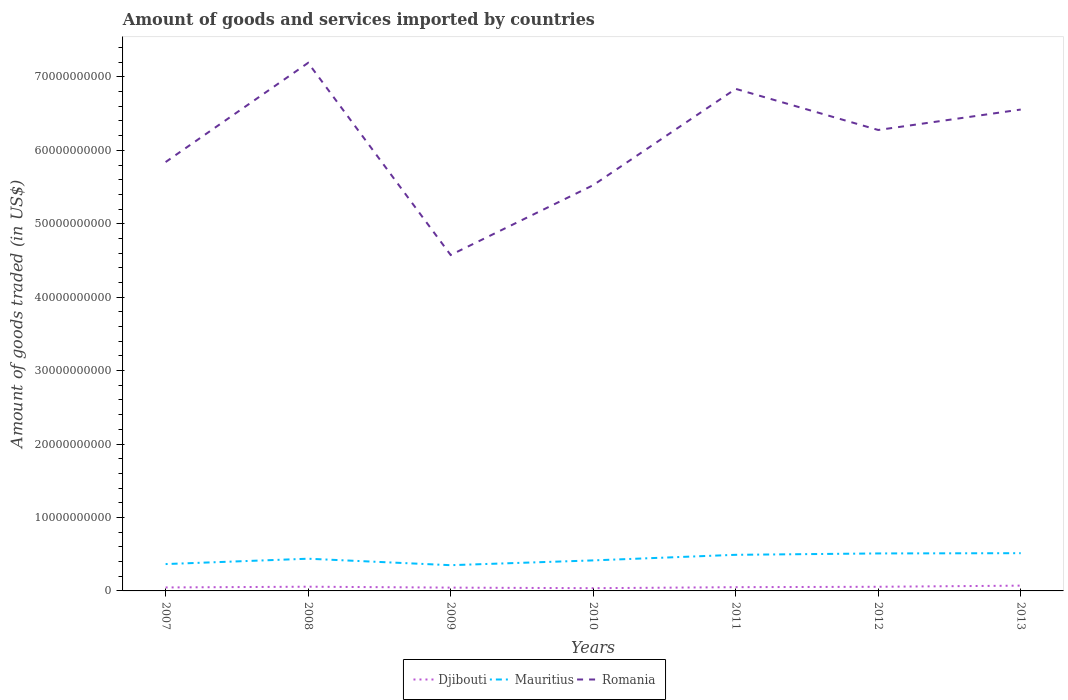Does the line corresponding to Djibouti intersect with the line corresponding to Romania?
Offer a terse response. No. Is the number of lines equal to the number of legend labels?
Offer a terse response. Yes. Across all years, what is the maximum total amount of goods and services imported in Mauritius?
Give a very brief answer. 3.50e+09. In which year was the total amount of goods and services imported in Romania maximum?
Give a very brief answer. 2009. What is the total total amount of goods and services imported in Romania in the graph?
Offer a very short reply. 5.60e+09. What is the difference between the highest and the second highest total amount of goods and services imported in Djibouti?
Offer a very short reply. 3.46e+08. Is the total amount of goods and services imported in Mauritius strictly greater than the total amount of goods and services imported in Djibouti over the years?
Your answer should be compact. No. What is the difference between two consecutive major ticks on the Y-axis?
Provide a succinct answer. 1.00e+1. Does the graph contain any zero values?
Your answer should be compact. No. Does the graph contain grids?
Provide a succinct answer. No. Where does the legend appear in the graph?
Provide a succinct answer. Bottom center. What is the title of the graph?
Your answer should be very brief. Amount of goods and services imported by countries. Does "Bahrain" appear as one of the legend labels in the graph?
Keep it short and to the point. No. What is the label or title of the Y-axis?
Your answer should be compact. Amount of goods traded (in US$). What is the Amount of goods traded (in US$) of Djibouti in 2007?
Provide a succinct answer. 4.73e+08. What is the Amount of goods traded (in US$) in Mauritius in 2007?
Offer a terse response. 3.66e+09. What is the Amount of goods traded (in US$) of Romania in 2007?
Offer a terse response. 5.84e+1. What is the Amount of goods traded (in US$) of Djibouti in 2008?
Your response must be concise. 5.74e+08. What is the Amount of goods traded (in US$) in Mauritius in 2008?
Provide a succinct answer. 4.39e+09. What is the Amount of goods traded (in US$) in Romania in 2008?
Your answer should be very brief. 7.19e+1. What is the Amount of goods traded (in US$) in Djibouti in 2009?
Give a very brief answer. 4.51e+08. What is the Amount of goods traded (in US$) of Mauritius in 2009?
Your response must be concise. 3.50e+09. What is the Amount of goods traded (in US$) of Romania in 2009?
Provide a succinct answer. 4.57e+1. What is the Amount of goods traded (in US$) of Djibouti in 2010?
Offer a very short reply. 3.74e+08. What is the Amount of goods traded (in US$) in Mauritius in 2010?
Your answer should be very brief. 4.16e+09. What is the Amount of goods traded (in US$) in Romania in 2010?
Provide a short and direct response. 5.53e+1. What is the Amount of goods traded (in US$) of Djibouti in 2011?
Make the answer very short. 5.11e+08. What is the Amount of goods traded (in US$) in Mauritius in 2011?
Your answer should be compact. 4.92e+09. What is the Amount of goods traded (in US$) in Romania in 2011?
Make the answer very short. 6.84e+1. What is the Amount of goods traded (in US$) in Djibouti in 2012?
Your response must be concise. 5.64e+08. What is the Amount of goods traded (in US$) of Mauritius in 2012?
Give a very brief answer. 5.10e+09. What is the Amount of goods traded (in US$) in Romania in 2012?
Your answer should be compact. 6.28e+1. What is the Amount of goods traded (in US$) of Djibouti in 2013?
Give a very brief answer. 7.19e+08. What is the Amount of goods traded (in US$) in Mauritius in 2013?
Ensure brevity in your answer.  5.14e+09. What is the Amount of goods traded (in US$) in Romania in 2013?
Your answer should be very brief. 6.56e+1. Across all years, what is the maximum Amount of goods traded (in US$) of Djibouti?
Your answer should be very brief. 7.19e+08. Across all years, what is the maximum Amount of goods traded (in US$) in Mauritius?
Provide a short and direct response. 5.14e+09. Across all years, what is the maximum Amount of goods traded (in US$) in Romania?
Your answer should be compact. 7.19e+1. Across all years, what is the minimum Amount of goods traded (in US$) in Djibouti?
Your answer should be compact. 3.74e+08. Across all years, what is the minimum Amount of goods traded (in US$) in Mauritius?
Make the answer very short. 3.50e+09. Across all years, what is the minimum Amount of goods traded (in US$) of Romania?
Make the answer very short. 4.57e+1. What is the total Amount of goods traded (in US$) in Djibouti in the graph?
Make the answer very short. 3.67e+09. What is the total Amount of goods traded (in US$) in Mauritius in the graph?
Keep it short and to the point. 3.09e+1. What is the total Amount of goods traded (in US$) in Romania in the graph?
Your answer should be very brief. 4.28e+11. What is the difference between the Amount of goods traded (in US$) in Djibouti in 2007 and that in 2008?
Give a very brief answer. -1.01e+08. What is the difference between the Amount of goods traded (in US$) in Mauritius in 2007 and that in 2008?
Make the answer very short. -7.30e+08. What is the difference between the Amount of goods traded (in US$) of Romania in 2007 and that in 2008?
Offer a terse response. -1.35e+1. What is the difference between the Amount of goods traded (in US$) of Djibouti in 2007 and that in 2009?
Your answer should be compact. 2.25e+07. What is the difference between the Amount of goods traded (in US$) in Mauritius in 2007 and that in 2009?
Your answer should be very brief. 1.52e+08. What is the difference between the Amount of goods traded (in US$) of Romania in 2007 and that in 2009?
Keep it short and to the point. 1.27e+1. What is the difference between the Amount of goods traded (in US$) of Djibouti in 2007 and that in 2010?
Make the answer very short. 9.93e+07. What is the difference between the Amount of goods traded (in US$) in Mauritius in 2007 and that in 2010?
Provide a short and direct response. -5.01e+08. What is the difference between the Amount of goods traded (in US$) of Romania in 2007 and that in 2010?
Provide a succinct answer. 3.15e+09. What is the difference between the Amount of goods traded (in US$) of Djibouti in 2007 and that in 2011?
Make the answer very short. -3.74e+07. What is the difference between the Amount of goods traded (in US$) of Mauritius in 2007 and that in 2011?
Offer a terse response. -1.26e+09. What is the difference between the Amount of goods traded (in US$) of Romania in 2007 and that in 2011?
Provide a short and direct response. -9.97e+09. What is the difference between the Amount of goods traded (in US$) in Djibouti in 2007 and that in 2012?
Give a very brief answer. -9.12e+07. What is the difference between the Amount of goods traded (in US$) in Mauritius in 2007 and that in 2012?
Your answer should be very brief. -1.45e+09. What is the difference between the Amount of goods traded (in US$) in Romania in 2007 and that in 2012?
Provide a succinct answer. -4.37e+09. What is the difference between the Amount of goods traded (in US$) of Djibouti in 2007 and that in 2013?
Your answer should be very brief. -2.46e+08. What is the difference between the Amount of goods traded (in US$) in Mauritius in 2007 and that in 2013?
Your answer should be very brief. -1.48e+09. What is the difference between the Amount of goods traded (in US$) of Romania in 2007 and that in 2013?
Provide a short and direct response. -7.15e+09. What is the difference between the Amount of goods traded (in US$) of Djibouti in 2008 and that in 2009?
Your answer should be compact. 1.23e+08. What is the difference between the Amount of goods traded (in US$) in Mauritius in 2008 and that in 2009?
Provide a succinct answer. 8.82e+08. What is the difference between the Amount of goods traded (in US$) of Romania in 2008 and that in 2009?
Provide a short and direct response. 2.62e+1. What is the difference between the Amount of goods traded (in US$) in Djibouti in 2008 and that in 2010?
Your answer should be compact. 2.00e+08. What is the difference between the Amount of goods traded (in US$) of Mauritius in 2008 and that in 2010?
Your response must be concise. 2.29e+08. What is the difference between the Amount of goods traded (in US$) of Romania in 2008 and that in 2010?
Provide a short and direct response. 1.67e+1. What is the difference between the Amount of goods traded (in US$) of Djibouti in 2008 and that in 2011?
Offer a terse response. 6.36e+07. What is the difference between the Amount of goods traded (in US$) in Mauritius in 2008 and that in 2011?
Provide a succinct answer. -5.31e+08. What is the difference between the Amount of goods traded (in US$) in Romania in 2008 and that in 2011?
Your answer should be very brief. 3.54e+09. What is the difference between the Amount of goods traded (in US$) of Djibouti in 2008 and that in 2012?
Offer a very short reply. 9.70e+06. What is the difference between the Amount of goods traded (in US$) in Mauritius in 2008 and that in 2012?
Offer a very short reply. -7.19e+08. What is the difference between the Amount of goods traded (in US$) of Romania in 2008 and that in 2012?
Provide a succinct answer. 9.14e+09. What is the difference between the Amount of goods traded (in US$) of Djibouti in 2008 and that in 2013?
Your answer should be very brief. -1.45e+08. What is the difference between the Amount of goods traded (in US$) in Mauritius in 2008 and that in 2013?
Offer a terse response. -7.53e+08. What is the difference between the Amount of goods traded (in US$) of Romania in 2008 and that in 2013?
Provide a short and direct response. 6.36e+09. What is the difference between the Amount of goods traded (in US$) in Djibouti in 2009 and that in 2010?
Offer a terse response. 7.68e+07. What is the difference between the Amount of goods traded (in US$) in Mauritius in 2009 and that in 2010?
Make the answer very short. -6.53e+08. What is the difference between the Amount of goods traded (in US$) of Romania in 2009 and that in 2010?
Offer a terse response. -9.51e+09. What is the difference between the Amount of goods traded (in US$) in Djibouti in 2009 and that in 2011?
Make the answer very short. -5.99e+07. What is the difference between the Amount of goods traded (in US$) of Mauritius in 2009 and that in 2011?
Give a very brief answer. -1.41e+09. What is the difference between the Amount of goods traded (in US$) in Romania in 2009 and that in 2011?
Offer a very short reply. -2.26e+1. What is the difference between the Amount of goods traded (in US$) in Djibouti in 2009 and that in 2012?
Your answer should be compact. -1.14e+08. What is the difference between the Amount of goods traded (in US$) of Mauritius in 2009 and that in 2012?
Offer a very short reply. -1.60e+09. What is the difference between the Amount of goods traded (in US$) in Romania in 2009 and that in 2012?
Your answer should be very brief. -1.70e+1. What is the difference between the Amount of goods traded (in US$) in Djibouti in 2009 and that in 2013?
Your response must be concise. -2.69e+08. What is the difference between the Amount of goods traded (in US$) in Mauritius in 2009 and that in 2013?
Provide a short and direct response. -1.64e+09. What is the difference between the Amount of goods traded (in US$) in Romania in 2009 and that in 2013?
Your answer should be very brief. -1.98e+1. What is the difference between the Amount of goods traded (in US$) in Djibouti in 2010 and that in 2011?
Keep it short and to the point. -1.37e+08. What is the difference between the Amount of goods traded (in US$) of Mauritius in 2010 and that in 2011?
Provide a succinct answer. -7.61e+08. What is the difference between the Amount of goods traded (in US$) in Romania in 2010 and that in 2011?
Make the answer very short. -1.31e+1. What is the difference between the Amount of goods traded (in US$) of Djibouti in 2010 and that in 2012?
Your answer should be compact. -1.91e+08. What is the difference between the Amount of goods traded (in US$) of Mauritius in 2010 and that in 2012?
Give a very brief answer. -9.48e+08. What is the difference between the Amount of goods traded (in US$) in Romania in 2010 and that in 2012?
Your answer should be compact. -7.52e+09. What is the difference between the Amount of goods traded (in US$) in Djibouti in 2010 and that in 2013?
Give a very brief answer. -3.46e+08. What is the difference between the Amount of goods traded (in US$) in Mauritius in 2010 and that in 2013?
Make the answer very short. -9.82e+08. What is the difference between the Amount of goods traded (in US$) of Romania in 2010 and that in 2013?
Make the answer very short. -1.03e+1. What is the difference between the Amount of goods traded (in US$) in Djibouti in 2011 and that in 2012?
Ensure brevity in your answer.  -5.39e+07. What is the difference between the Amount of goods traded (in US$) of Mauritius in 2011 and that in 2012?
Give a very brief answer. -1.87e+08. What is the difference between the Amount of goods traded (in US$) in Romania in 2011 and that in 2012?
Provide a short and direct response. 5.60e+09. What is the difference between the Amount of goods traded (in US$) in Djibouti in 2011 and that in 2013?
Offer a terse response. -2.09e+08. What is the difference between the Amount of goods traded (in US$) of Mauritius in 2011 and that in 2013?
Give a very brief answer. -2.22e+08. What is the difference between the Amount of goods traded (in US$) of Romania in 2011 and that in 2013?
Keep it short and to the point. 2.82e+09. What is the difference between the Amount of goods traded (in US$) of Djibouti in 2012 and that in 2013?
Your answer should be compact. -1.55e+08. What is the difference between the Amount of goods traded (in US$) of Mauritius in 2012 and that in 2013?
Provide a succinct answer. -3.42e+07. What is the difference between the Amount of goods traded (in US$) of Romania in 2012 and that in 2013?
Make the answer very short. -2.78e+09. What is the difference between the Amount of goods traded (in US$) of Djibouti in 2007 and the Amount of goods traded (in US$) of Mauritius in 2008?
Provide a short and direct response. -3.91e+09. What is the difference between the Amount of goods traded (in US$) in Djibouti in 2007 and the Amount of goods traded (in US$) in Romania in 2008?
Ensure brevity in your answer.  -7.14e+1. What is the difference between the Amount of goods traded (in US$) in Mauritius in 2007 and the Amount of goods traded (in US$) in Romania in 2008?
Give a very brief answer. -6.83e+1. What is the difference between the Amount of goods traded (in US$) in Djibouti in 2007 and the Amount of goods traded (in US$) in Mauritius in 2009?
Your answer should be very brief. -3.03e+09. What is the difference between the Amount of goods traded (in US$) of Djibouti in 2007 and the Amount of goods traded (in US$) of Romania in 2009?
Ensure brevity in your answer.  -4.53e+1. What is the difference between the Amount of goods traded (in US$) of Mauritius in 2007 and the Amount of goods traded (in US$) of Romania in 2009?
Keep it short and to the point. -4.21e+1. What is the difference between the Amount of goods traded (in US$) of Djibouti in 2007 and the Amount of goods traded (in US$) of Mauritius in 2010?
Make the answer very short. -3.68e+09. What is the difference between the Amount of goods traded (in US$) in Djibouti in 2007 and the Amount of goods traded (in US$) in Romania in 2010?
Your response must be concise. -5.48e+1. What is the difference between the Amount of goods traded (in US$) in Mauritius in 2007 and the Amount of goods traded (in US$) in Romania in 2010?
Your response must be concise. -5.16e+1. What is the difference between the Amount of goods traded (in US$) of Djibouti in 2007 and the Amount of goods traded (in US$) of Mauritius in 2011?
Provide a short and direct response. -4.44e+09. What is the difference between the Amount of goods traded (in US$) in Djibouti in 2007 and the Amount of goods traded (in US$) in Romania in 2011?
Provide a short and direct response. -6.79e+1. What is the difference between the Amount of goods traded (in US$) of Mauritius in 2007 and the Amount of goods traded (in US$) of Romania in 2011?
Your answer should be very brief. -6.47e+1. What is the difference between the Amount of goods traded (in US$) of Djibouti in 2007 and the Amount of goods traded (in US$) of Mauritius in 2012?
Make the answer very short. -4.63e+09. What is the difference between the Amount of goods traded (in US$) in Djibouti in 2007 and the Amount of goods traded (in US$) in Romania in 2012?
Offer a very short reply. -6.23e+1. What is the difference between the Amount of goods traded (in US$) in Mauritius in 2007 and the Amount of goods traded (in US$) in Romania in 2012?
Your answer should be very brief. -5.91e+1. What is the difference between the Amount of goods traded (in US$) of Djibouti in 2007 and the Amount of goods traded (in US$) of Mauritius in 2013?
Provide a succinct answer. -4.67e+09. What is the difference between the Amount of goods traded (in US$) in Djibouti in 2007 and the Amount of goods traded (in US$) in Romania in 2013?
Ensure brevity in your answer.  -6.51e+1. What is the difference between the Amount of goods traded (in US$) in Mauritius in 2007 and the Amount of goods traded (in US$) in Romania in 2013?
Your answer should be very brief. -6.19e+1. What is the difference between the Amount of goods traded (in US$) in Djibouti in 2008 and the Amount of goods traded (in US$) in Mauritius in 2009?
Give a very brief answer. -2.93e+09. What is the difference between the Amount of goods traded (in US$) of Djibouti in 2008 and the Amount of goods traded (in US$) of Romania in 2009?
Your answer should be compact. -4.52e+1. What is the difference between the Amount of goods traded (in US$) of Mauritius in 2008 and the Amount of goods traded (in US$) of Romania in 2009?
Keep it short and to the point. -4.14e+1. What is the difference between the Amount of goods traded (in US$) of Djibouti in 2008 and the Amount of goods traded (in US$) of Mauritius in 2010?
Your answer should be compact. -3.58e+09. What is the difference between the Amount of goods traded (in US$) in Djibouti in 2008 and the Amount of goods traded (in US$) in Romania in 2010?
Ensure brevity in your answer.  -5.47e+1. What is the difference between the Amount of goods traded (in US$) in Mauritius in 2008 and the Amount of goods traded (in US$) in Romania in 2010?
Your answer should be very brief. -5.09e+1. What is the difference between the Amount of goods traded (in US$) in Djibouti in 2008 and the Amount of goods traded (in US$) in Mauritius in 2011?
Ensure brevity in your answer.  -4.34e+09. What is the difference between the Amount of goods traded (in US$) of Djibouti in 2008 and the Amount of goods traded (in US$) of Romania in 2011?
Keep it short and to the point. -6.78e+1. What is the difference between the Amount of goods traded (in US$) of Mauritius in 2008 and the Amount of goods traded (in US$) of Romania in 2011?
Your answer should be compact. -6.40e+1. What is the difference between the Amount of goods traded (in US$) in Djibouti in 2008 and the Amount of goods traded (in US$) in Mauritius in 2012?
Your answer should be compact. -4.53e+09. What is the difference between the Amount of goods traded (in US$) of Djibouti in 2008 and the Amount of goods traded (in US$) of Romania in 2012?
Your answer should be very brief. -6.22e+1. What is the difference between the Amount of goods traded (in US$) in Mauritius in 2008 and the Amount of goods traded (in US$) in Romania in 2012?
Provide a short and direct response. -5.84e+1. What is the difference between the Amount of goods traded (in US$) in Djibouti in 2008 and the Amount of goods traded (in US$) in Mauritius in 2013?
Offer a very short reply. -4.56e+09. What is the difference between the Amount of goods traded (in US$) in Djibouti in 2008 and the Amount of goods traded (in US$) in Romania in 2013?
Your answer should be compact. -6.50e+1. What is the difference between the Amount of goods traded (in US$) of Mauritius in 2008 and the Amount of goods traded (in US$) of Romania in 2013?
Ensure brevity in your answer.  -6.12e+1. What is the difference between the Amount of goods traded (in US$) in Djibouti in 2009 and the Amount of goods traded (in US$) in Mauritius in 2010?
Provide a succinct answer. -3.71e+09. What is the difference between the Amount of goods traded (in US$) of Djibouti in 2009 and the Amount of goods traded (in US$) of Romania in 2010?
Your answer should be very brief. -5.48e+1. What is the difference between the Amount of goods traded (in US$) of Mauritius in 2009 and the Amount of goods traded (in US$) of Romania in 2010?
Provide a succinct answer. -5.17e+1. What is the difference between the Amount of goods traded (in US$) of Djibouti in 2009 and the Amount of goods traded (in US$) of Mauritius in 2011?
Make the answer very short. -4.47e+09. What is the difference between the Amount of goods traded (in US$) in Djibouti in 2009 and the Amount of goods traded (in US$) in Romania in 2011?
Ensure brevity in your answer.  -6.79e+1. What is the difference between the Amount of goods traded (in US$) of Mauritius in 2009 and the Amount of goods traded (in US$) of Romania in 2011?
Ensure brevity in your answer.  -6.49e+1. What is the difference between the Amount of goods traded (in US$) in Djibouti in 2009 and the Amount of goods traded (in US$) in Mauritius in 2012?
Make the answer very short. -4.65e+09. What is the difference between the Amount of goods traded (in US$) in Djibouti in 2009 and the Amount of goods traded (in US$) in Romania in 2012?
Keep it short and to the point. -6.23e+1. What is the difference between the Amount of goods traded (in US$) in Mauritius in 2009 and the Amount of goods traded (in US$) in Romania in 2012?
Keep it short and to the point. -5.93e+1. What is the difference between the Amount of goods traded (in US$) of Djibouti in 2009 and the Amount of goods traded (in US$) of Mauritius in 2013?
Provide a short and direct response. -4.69e+09. What is the difference between the Amount of goods traded (in US$) of Djibouti in 2009 and the Amount of goods traded (in US$) of Romania in 2013?
Offer a terse response. -6.51e+1. What is the difference between the Amount of goods traded (in US$) of Mauritius in 2009 and the Amount of goods traded (in US$) of Romania in 2013?
Offer a terse response. -6.20e+1. What is the difference between the Amount of goods traded (in US$) in Djibouti in 2010 and the Amount of goods traded (in US$) in Mauritius in 2011?
Keep it short and to the point. -4.54e+09. What is the difference between the Amount of goods traded (in US$) of Djibouti in 2010 and the Amount of goods traded (in US$) of Romania in 2011?
Offer a very short reply. -6.80e+1. What is the difference between the Amount of goods traded (in US$) of Mauritius in 2010 and the Amount of goods traded (in US$) of Romania in 2011?
Keep it short and to the point. -6.42e+1. What is the difference between the Amount of goods traded (in US$) in Djibouti in 2010 and the Amount of goods traded (in US$) in Mauritius in 2012?
Provide a short and direct response. -4.73e+09. What is the difference between the Amount of goods traded (in US$) in Djibouti in 2010 and the Amount of goods traded (in US$) in Romania in 2012?
Your answer should be compact. -6.24e+1. What is the difference between the Amount of goods traded (in US$) in Mauritius in 2010 and the Amount of goods traded (in US$) in Romania in 2012?
Ensure brevity in your answer.  -5.86e+1. What is the difference between the Amount of goods traded (in US$) of Djibouti in 2010 and the Amount of goods traded (in US$) of Mauritius in 2013?
Provide a succinct answer. -4.77e+09. What is the difference between the Amount of goods traded (in US$) in Djibouti in 2010 and the Amount of goods traded (in US$) in Romania in 2013?
Your answer should be compact. -6.52e+1. What is the difference between the Amount of goods traded (in US$) of Mauritius in 2010 and the Amount of goods traded (in US$) of Romania in 2013?
Offer a terse response. -6.14e+1. What is the difference between the Amount of goods traded (in US$) of Djibouti in 2011 and the Amount of goods traded (in US$) of Mauritius in 2012?
Offer a terse response. -4.59e+09. What is the difference between the Amount of goods traded (in US$) of Djibouti in 2011 and the Amount of goods traded (in US$) of Romania in 2012?
Keep it short and to the point. -6.23e+1. What is the difference between the Amount of goods traded (in US$) in Mauritius in 2011 and the Amount of goods traded (in US$) in Romania in 2012?
Offer a terse response. -5.79e+1. What is the difference between the Amount of goods traded (in US$) of Djibouti in 2011 and the Amount of goods traded (in US$) of Mauritius in 2013?
Give a very brief answer. -4.63e+09. What is the difference between the Amount of goods traded (in US$) in Djibouti in 2011 and the Amount of goods traded (in US$) in Romania in 2013?
Give a very brief answer. -6.50e+1. What is the difference between the Amount of goods traded (in US$) of Mauritius in 2011 and the Amount of goods traded (in US$) of Romania in 2013?
Your answer should be compact. -6.06e+1. What is the difference between the Amount of goods traded (in US$) in Djibouti in 2012 and the Amount of goods traded (in US$) in Mauritius in 2013?
Provide a succinct answer. -4.57e+09. What is the difference between the Amount of goods traded (in US$) in Djibouti in 2012 and the Amount of goods traded (in US$) in Romania in 2013?
Your response must be concise. -6.50e+1. What is the difference between the Amount of goods traded (in US$) in Mauritius in 2012 and the Amount of goods traded (in US$) in Romania in 2013?
Make the answer very short. -6.04e+1. What is the average Amount of goods traded (in US$) of Djibouti per year?
Ensure brevity in your answer.  5.24e+08. What is the average Amount of goods traded (in US$) in Mauritius per year?
Your answer should be compact. 4.41e+09. What is the average Amount of goods traded (in US$) of Romania per year?
Provide a succinct answer. 6.11e+1. In the year 2007, what is the difference between the Amount of goods traded (in US$) in Djibouti and Amount of goods traded (in US$) in Mauritius?
Make the answer very short. -3.18e+09. In the year 2007, what is the difference between the Amount of goods traded (in US$) in Djibouti and Amount of goods traded (in US$) in Romania?
Keep it short and to the point. -5.79e+1. In the year 2007, what is the difference between the Amount of goods traded (in US$) of Mauritius and Amount of goods traded (in US$) of Romania?
Ensure brevity in your answer.  -5.47e+1. In the year 2008, what is the difference between the Amount of goods traded (in US$) of Djibouti and Amount of goods traded (in US$) of Mauritius?
Ensure brevity in your answer.  -3.81e+09. In the year 2008, what is the difference between the Amount of goods traded (in US$) of Djibouti and Amount of goods traded (in US$) of Romania?
Your response must be concise. -7.13e+1. In the year 2008, what is the difference between the Amount of goods traded (in US$) in Mauritius and Amount of goods traded (in US$) in Romania?
Provide a short and direct response. -6.75e+1. In the year 2009, what is the difference between the Amount of goods traded (in US$) of Djibouti and Amount of goods traded (in US$) of Mauritius?
Your answer should be very brief. -3.05e+09. In the year 2009, what is the difference between the Amount of goods traded (in US$) in Djibouti and Amount of goods traded (in US$) in Romania?
Give a very brief answer. -4.53e+1. In the year 2009, what is the difference between the Amount of goods traded (in US$) of Mauritius and Amount of goods traded (in US$) of Romania?
Make the answer very short. -4.22e+1. In the year 2010, what is the difference between the Amount of goods traded (in US$) of Djibouti and Amount of goods traded (in US$) of Mauritius?
Provide a succinct answer. -3.78e+09. In the year 2010, what is the difference between the Amount of goods traded (in US$) of Djibouti and Amount of goods traded (in US$) of Romania?
Your answer should be compact. -5.49e+1. In the year 2010, what is the difference between the Amount of goods traded (in US$) of Mauritius and Amount of goods traded (in US$) of Romania?
Your answer should be compact. -5.11e+1. In the year 2011, what is the difference between the Amount of goods traded (in US$) in Djibouti and Amount of goods traded (in US$) in Mauritius?
Keep it short and to the point. -4.41e+09. In the year 2011, what is the difference between the Amount of goods traded (in US$) of Djibouti and Amount of goods traded (in US$) of Romania?
Your response must be concise. -6.79e+1. In the year 2011, what is the difference between the Amount of goods traded (in US$) of Mauritius and Amount of goods traded (in US$) of Romania?
Provide a short and direct response. -6.35e+1. In the year 2012, what is the difference between the Amount of goods traded (in US$) of Djibouti and Amount of goods traded (in US$) of Mauritius?
Provide a succinct answer. -4.54e+09. In the year 2012, what is the difference between the Amount of goods traded (in US$) in Djibouti and Amount of goods traded (in US$) in Romania?
Make the answer very short. -6.22e+1. In the year 2012, what is the difference between the Amount of goods traded (in US$) in Mauritius and Amount of goods traded (in US$) in Romania?
Offer a terse response. -5.77e+1. In the year 2013, what is the difference between the Amount of goods traded (in US$) in Djibouti and Amount of goods traded (in US$) in Mauritius?
Your response must be concise. -4.42e+09. In the year 2013, what is the difference between the Amount of goods traded (in US$) in Djibouti and Amount of goods traded (in US$) in Romania?
Make the answer very short. -6.48e+1. In the year 2013, what is the difference between the Amount of goods traded (in US$) in Mauritius and Amount of goods traded (in US$) in Romania?
Make the answer very short. -6.04e+1. What is the ratio of the Amount of goods traded (in US$) of Djibouti in 2007 to that in 2008?
Provide a short and direct response. 0.82. What is the ratio of the Amount of goods traded (in US$) of Mauritius in 2007 to that in 2008?
Make the answer very short. 0.83. What is the ratio of the Amount of goods traded (in US$) of Romania in 2007 to that in 2008?
Make the answer very short. 0.81. What is the ratio of the Amount of goods traded (in US$) in Mauritius in 2007 to that in 2009?
Offer a very short reply. 1.04. What is the ratio of the Amount of goods traded (in US$) in Romania in 2007 to that in 2009?
Make the answer very short. 1.28. What is the ratio of the Amount of goods traded (in US$) of Djibouti in 2007 to that in 2010?
Provide a succinct answer. 1.27. What is the ratio of the Amount of goods traded (in US$) of Mauritius in 2007 to that in 2010?
Ensure brevity in your answer.  0.88. What is the ratio of the Amount of goods traded (in US$) in Romania in 2007 to that in 2010?
Keep it short and to the point. 1.06. What is the ratio of the Amount of goods traded (in US$) in Djibouti in 2007 to that in 2011?
Offer a terse response. 0.93. What is the ratio of the Amount of goods traded (in US$) in Mauritius in 2007 to that in 2011?
Make the answer very short. 0.74. What is the ratio of the Amount of goods traded (in US$) of Romania in 2007 to that in 2011?
Offer a terse response. 0.85. What is the ratio of the Amount of goods traded (in US$) in Djibouti in 2007 to that in 2012?
Your answer should be very brief. 0.84. What is the ratio of the Amount of goods traded (in US$) in Mauritius in 2007 to that in 2012?
Keep it short and to the point. 0.72. What is the ratio of the Amount of goods traded (in US$) in Romania in 2007 to that in 2012?
Your answer should be compact. 0.93. What is the ratio of the Amount of goods traded (in US$) in Djibouti in 2007 to that in 2013?
Offer a very short reply. 0.66. What is the ratio of the Amount of goods traded (in US$) in Mauritius in 2007 to that in 2013?
Your answer should be compact. 0.71. What is the ratio of the Amount of goods traded (in US$) in Romania in 2007 to that in 2013?
Your response must be concise. 0.89. What is the ratio of the Amount of goods traded (in US$) in Djibouti in 2008 to that in 2009?
Make the answer very short. 1.27. What is the ratio of the Amount of goods traded (in US$) in Mauritius in 2008 to that in 2009?
Your answer should be very brief. 1.25. What is the ratio of the Amount of goods traded (in US$) in Romania in 2008 to that in 2009?
Provide a succinct answer. 1.57. What is the ratio of the Amount of goods traded (in US$) in Djibouti in 2008 to that in 2010?
Keep it short and to the point. 1.54. What is the ratio of the Amount of goods traded (in US$) in Mauritius in 2008 to that in 2010?
Keep it short and to the point. 1.06. What is the ratio of the Amount of goods traded (in US$) of Romania in 2008 to that in 2010?
Provide a succinct answer. 1.3. What is the ratio of the Amount of goods traded (in US$) in Djibouti in 2008 to that in 2011?
Offer a very short reply. 1.12. What is the ratio of the Amount of goods traded (in US$) of Mauritius in 2008 to that in 2011?
Make the answer very short. 0.89. What is the ratio of the Amount of goods traded (in US$) of Romania in 2008 to that in 2011?
Keep it short and to the point. 1.05. What is the ratio of the Amount of goods traded (in US$) of Djibouti in 2008 to that in 2012?
Your response must be concise. 1.02. What is the ratio of the Amount of goods traded (in US$) of Mauritius in 2008 to that in 2012?
Give a very brief answer. 0.86. What is the ratio of the Amount of goods traded (in US$) of Romania in 2008 to that in 2012?
Ensure brevity in your answer.  1.15. What is the ratio of the Amount of goods traded (in US$) of Djibouti in 2008 to that in 2013?
Ensure brevity in your answer.  0.8. What is the ratio of the Amount of goods traded (in US$) of Mauritius in 2008 to that in 2013?
Ensure brevity in your answer.  0.85. What is the ratio of the Amount of goods traded (in US$) in Romania in 2008 to that in 2013?
Keep it short and to the point. 1.1. What is the ratio of the Amount of goods traded (in US$) in Djibouti in 2009 to that in 2010?
Offer a terse response. 1.21. What is the ratio of the Amount of goods traded (in US$) in Mauritius in 2009 to that in 2010?
Keep it short and to the point. 0.84. What is the ratio of the Amount of goods traded (in US$) of Romania in 2009 to that in 2010?
Offer a terse response. 0.83. What is the ratio of the Amount of goods traded (in US$) of Djibouti in 2009 to that in 2011?
Provide a succinct answer. 0.88. What is the ratio of the Amount of goods traded (in US$) in Mauritius in 2009 to that in 2011?
Your answer should be compact. 0.71. What is the ratio of the Amount of goods traded (in US$) of Romania in 2009 to that in 2011?
Make the answer very short. 0.67. What is the ratio of the Amount of goods traded (in US$) in Djibouti in 2009 to that in 2012?
Offer a terse response. 0.8. What is the ratio of the Amount of goods traded (in US$) in Mauritius in 2009 to that in 2012?
Your response must be concise. 0.69. What is the ratio of the Amount of goods traded (in US$) of Romania in 2009 to that in 2012?
Make the answer very short. 0.73. What is the ratio of the Amount of goods traded (in US$) of Djibouti in 2009 to that in 2013?
Your response must be concise. 0.63. What is the ratio of the Amount of goods traded (in US$) of Mauritius in 2009 to that in 2013?
Make the answer very short. 0.68. What is the ratio of the Amount of goods traded (in US$) in Romania in 2009 to that in 2013?
Make the answer very short. 0.7. What is the ratio of the Amount of goods traded (in US$) of Djibouti in 2010 to that in 2011?
Your answer should be compact. 0.73. What is the ratio of the Amount of goods traded (in US$) in Mauritius in 2010 to that in 2011?
Your answer should be compact. 0.85. What is the ratio of the Amount of goods traded (in US$) in Romania in 2010 to that in 2011?
Your response must be concise. 0.81. What is the ratio of the Amount of goods traded (in US$) in Djibouti in 2010 to that in 2012?
Provide a succinct answer. 0.66. What is the ratio of the Amount of goods traded (in US$) of Mauritius in 2010 to that in 2012?
Keep it short and to the point. 0.81. What is the ratio of the Amount of goods traded (in US$) in Romania in 2010 to that in 2012?
Offer a terse response. 0.88. What is the ratio of the Amount of goods traded (in US$) of Djibouti in 2010 to that in 2013?
Keep it short and to the point. 0.52. What is the ratio of the Amount of goods traded (in US$) in Mauritius in 2010 to that in 2013?
Your response must be concise. 0.81. What is the ratio of the Amount of goods traded (in US$) of Romania in 2010 to that in 2013?
Offer a very short reply. 0.84. What is the ratio of the Amount of goods traded (in US$) in Djibouti in 2011 to that in 2012?
Your response must be concise. 0.9. What is the ratio of the Amount of goods traded (in US$) of Mauritius in 2011 to that in 2012?
Your answer should be compact. 0.96. What is the ratio of the Amount of goods traded (in US$) of Romania in 2011 to that in 2012?
Make the answer very short. 1.09. What is the ratio of the Amount of goods traded (in US$) in Djibouti in 2011 to that in 2013?
Your response must be concise. 0.71. What is the ratio of the Amount of goods traded (in US$) in Mauritius in 2011 to that in 2013?
Your answer should be very brief. 0.96. What is the ratio of the Amount of goods traded (in US$) in Romania in 2011 to that in 2013?
Offer a very short reply. 1.04. What is the ratio of the Amount of goods traded (in US$) in Djibouti in 2012 to that in 2013?
Provide a succinct answer. 0.78. What is the ratio of the Amount of goods traded (in US$) of Romania in 2012 to that in 2013?
Your response must be concise. 0.96. What is the difference between the highest and the second highest Amount of goods traded (in US$) in Djibouti?
Make the answer very short. 1.45e+08. What is the difference between the highest and the second highest Amount of goods traded (in US$) of Mauritius?
Your response must be concise. 3.42e+07. What is the difference between the highest and the second highest Amount of goods traded (in US$) of Romania?
Offer a very short reply. 3.54e+09. What is the difference between the highest and the lowest Amount of goods traded (in US$) of Djibouti?
Your response must be concise. 3.46e+08. What is the difference between the highest and the lowest Amount of goods traded (in US$) in Mauritius?
Offer a terse response. 1.64e+09. What is the difference between the highest and the lowest Amount of goods traded (in US$) of Romania?
Your answer should be very brief. 2.62e+1. 